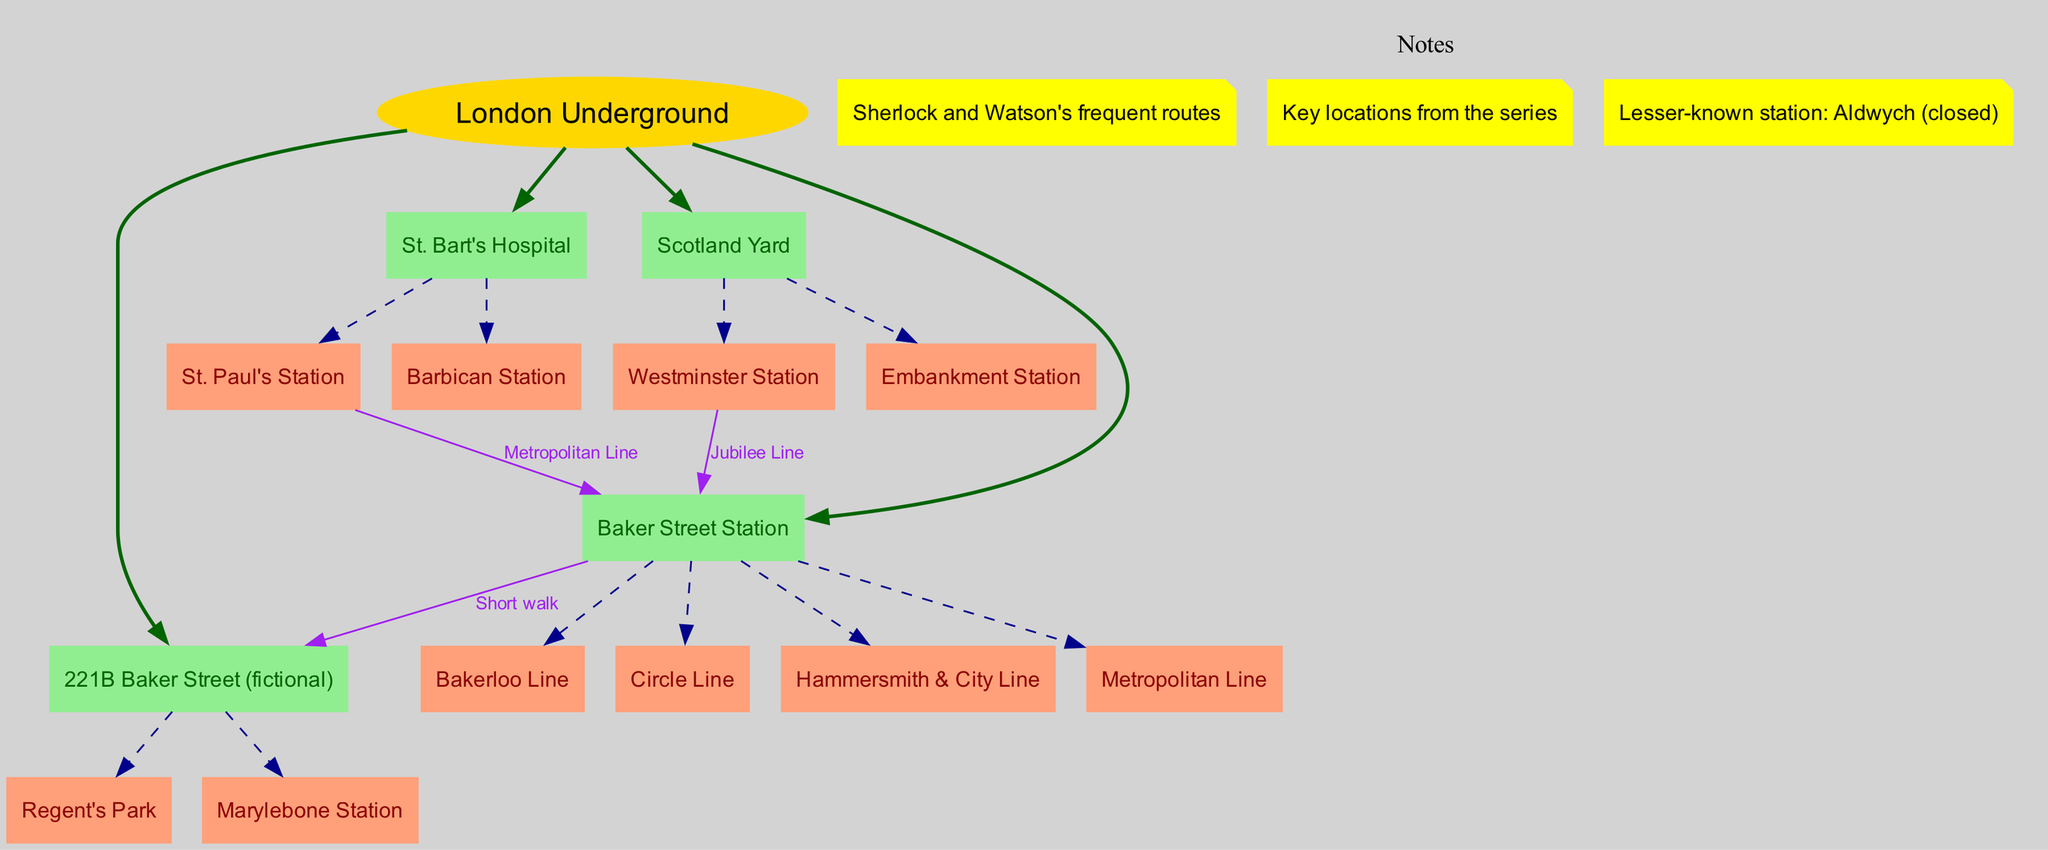What are the main branches of the London Underground according to the diagram? The diagram lists four main branches directly connected to the central node, which are Baker Street Station, 221B Baker Street (fictional), St. Bart's Hospital, and Scotland Yard.
Answer: Baker Street Station, 221B Baker Street (fictional), St. Bart's Hospital, Scotland Yard How many sub-branches does Baker Street Station have? The diagram indicates that Baker Street Station has four sub-branches: Bakerloo Line, Circle Line, Hammersmith & City Line, and Metropolitan Line. Therefore, the count of sub-branches is four.
Answer: 4 What station is connected to St. Paul's Station via the Metropolitan Line? According to the connection details in the diagram, St. Paul's Station is directly connected to Baker Street Station via the Metropolitan Line.
Answer: Baker Street Station Which fictional location is included as a main branch in the diagram? The diagram lists 221B Baker Street as a main branch, which is a fictional location associated with Sherlock Holmes and Dr. Watson's adventures.
Answer: 221B Baker Street (fictional) What color is used for the nodes representing sub-branches in the diagram? The color designated for sub-branch nodes in the diagram is lightsalmon, as indicated in the node style settings.
Answer: lightsalmon Which two stations can you reach by a short walk from Baker Street Station? The diagram reveals that 221B Baker Street (fictional) can be reached by a short walk from Baker Street Station, along with no other direct nearby options, separately.
Answer: 221B Baker Street (fictional) How many total connections are shown in the diagram? The diagram depicts three direct connections: Baker Street Station to 221B Baker Street (fictional), St. Paul's Station to Baker Street Station, and Westminster Station to Baker Street Station. Thus, the total number of connections is three.
Answer: 3 Which station is noted as lesser-known and is noted as closed? The diagram explicitly states that Aldwych is the lesser-known station mentioned in the notes, along with indicating that it is closed.
Answer: Aldwych (closed) 